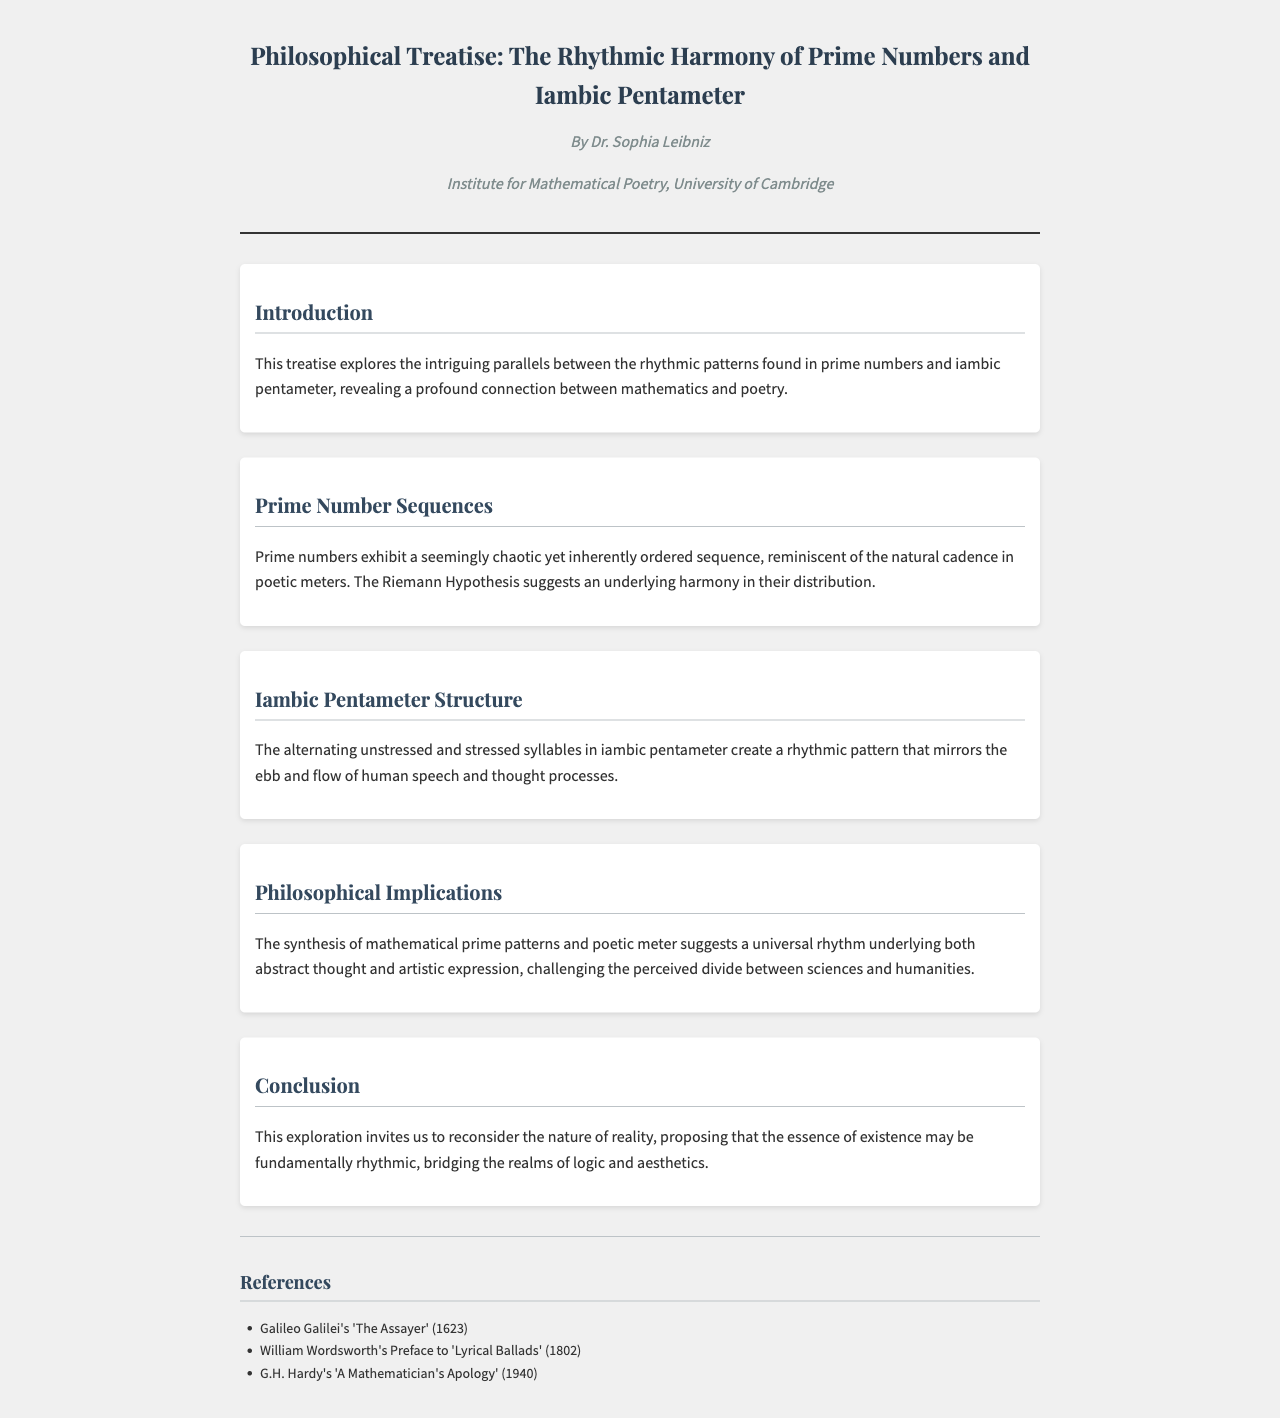What is the title of the treatise? The title of the treatise is presented prominently at the top of the document.
Answer: The Rhythmic Harmony of Prime Numbers and Iambic Pentameter Who is the author of the treatise? The author name is mentioned right below the title within the fax header.
Answer: Dr. Sophia Leibniz What institution is associated with the author? The institution is noted below the author's name in the fax header.
Answer: Institute for Mathematical Poetry, University of Cambridge What is the main focus of the treatise? The introduction outlines the central theme of the document.
Answer: Rhythmic patterns found in prime numbers and iambic pentameter What philosophical implication is suggested in the document? The implications are discussed in the section dedicated to philosophical insights.
Answer: A universal rhythm underlying both abstract thought and artistic expression In what year was G.H. Hardy's 'A Mathematician's Apology' published? The publication year is mentioned in the references section of the document.
Answer: 1940 What type of poetic meter is discussed in the treatise? The section on iambic pentameter specifies the type of meter being examined.
Answer: Iambic pentameter What hypothesis is mentioned regarding prime numbers? The hypothesis is referenced in the discussion of prime number sequences.
Answer: Riemann Hypothesis How many references are listed in the document? The references section provides a list of sources cited in the treatise.
Answer: Three 